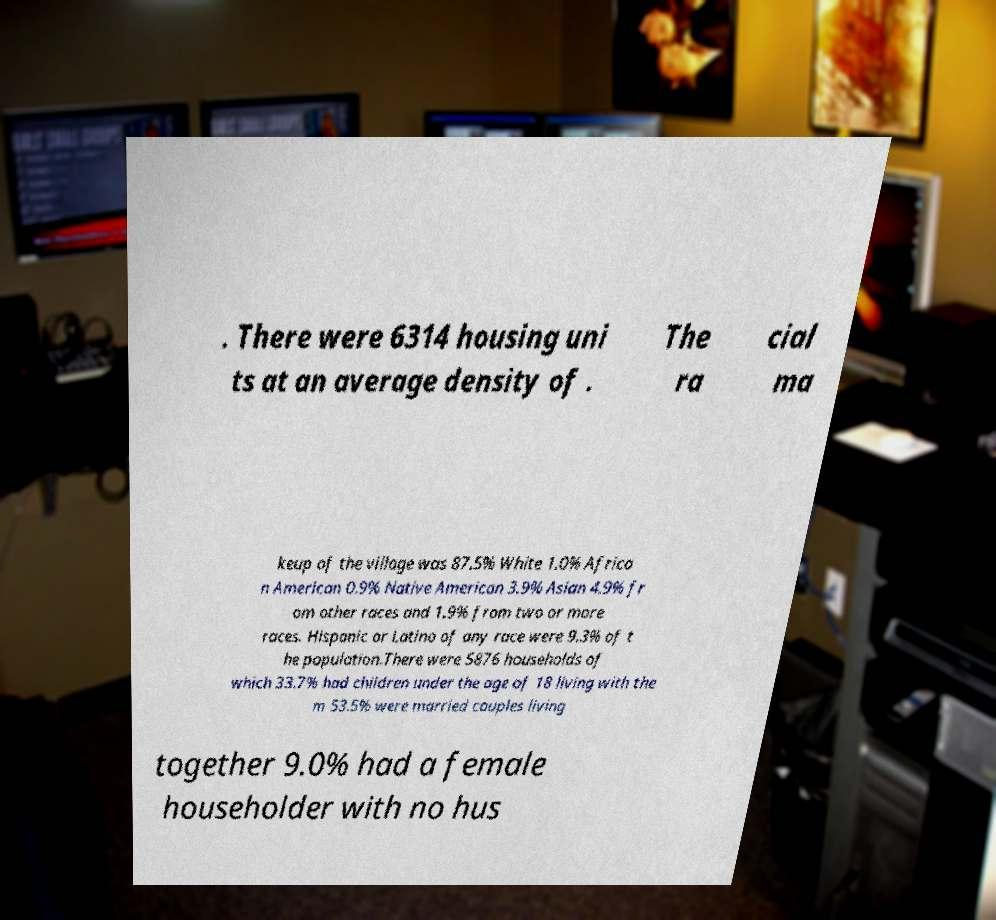Please read and relay the text visible in this image. What does it say? . There were 6314 housing uni ts at an average density of . The ra cial ma keup of the village was 87.5% White 1.0% Africa n American 0.9% Native American 3.9% Asian 4.9% fr om other races and 1.9% from two or more races. Hispanic or Latino of any race were 9.3% of t he population.There were 5876 households of which 33.7% had children under the age of 18 living with the m 53.5% were married couples living together 9.0% had a female householder with no hus 